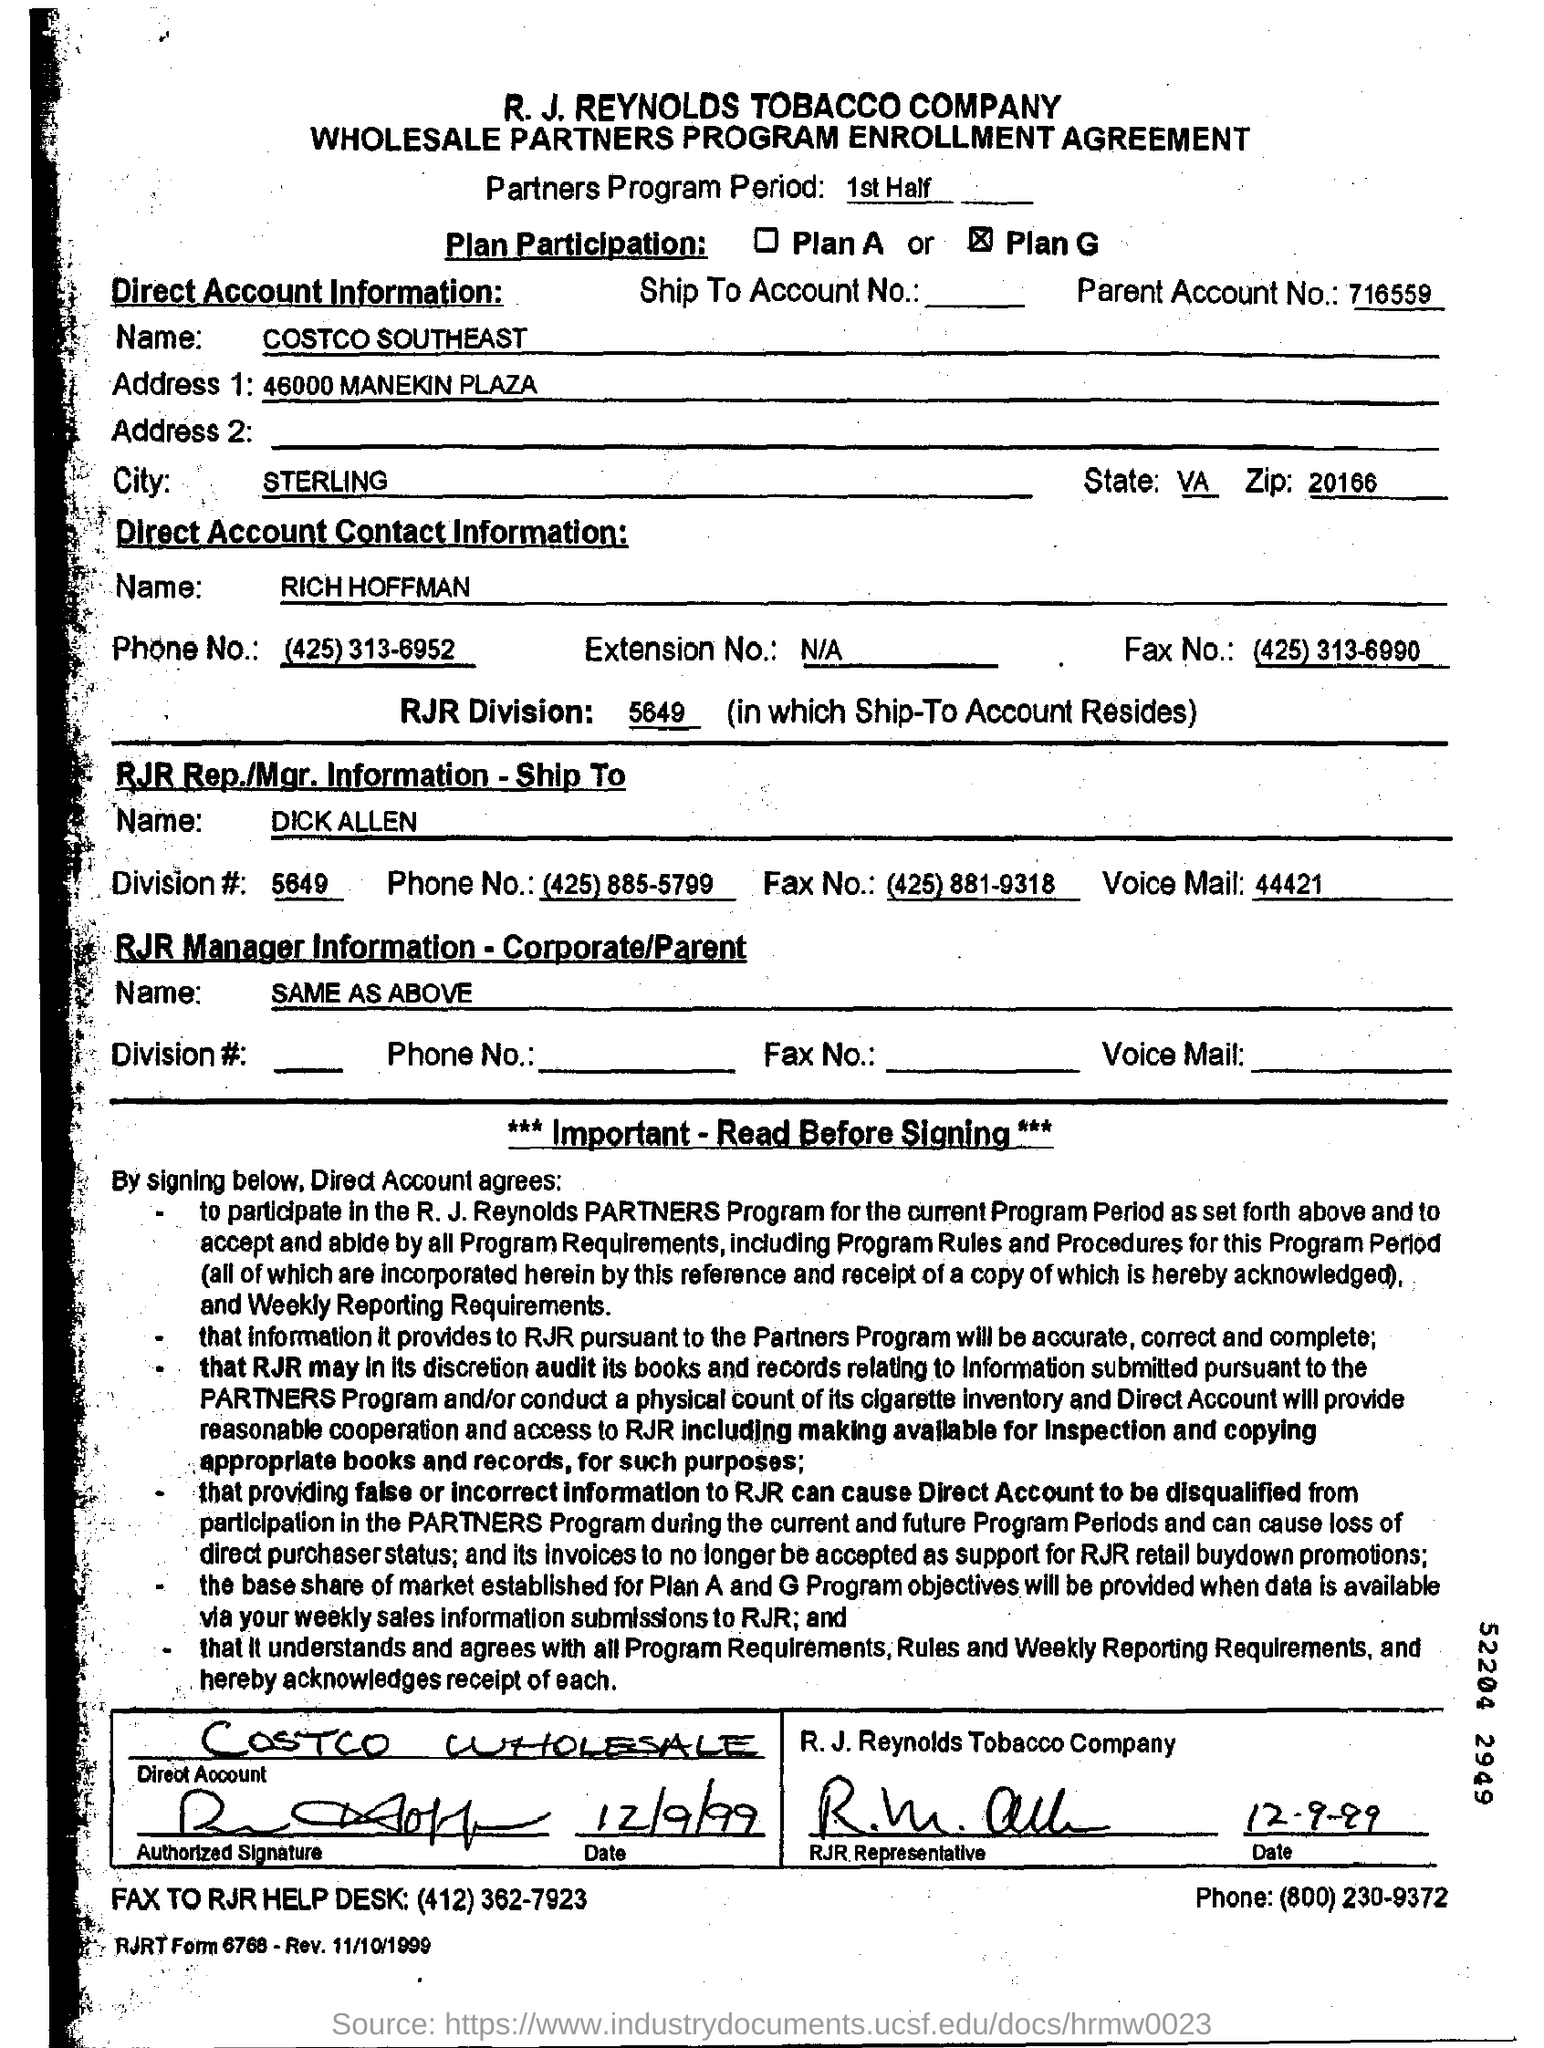Mention a couple of crucial points in this snapshot. The parent account number is 716559... The Direct Account contact person's name is RICH HOFFMAN. The RJR division is the specific grouping within a company or organization in which a ship-to account resides. This information can be used to better understand the context and purpose of the ship-to account within the organization. This is a Wholesale Partners Program Enrollment Agreement. The Partners Program Period 1st Half is a specified time frame. 